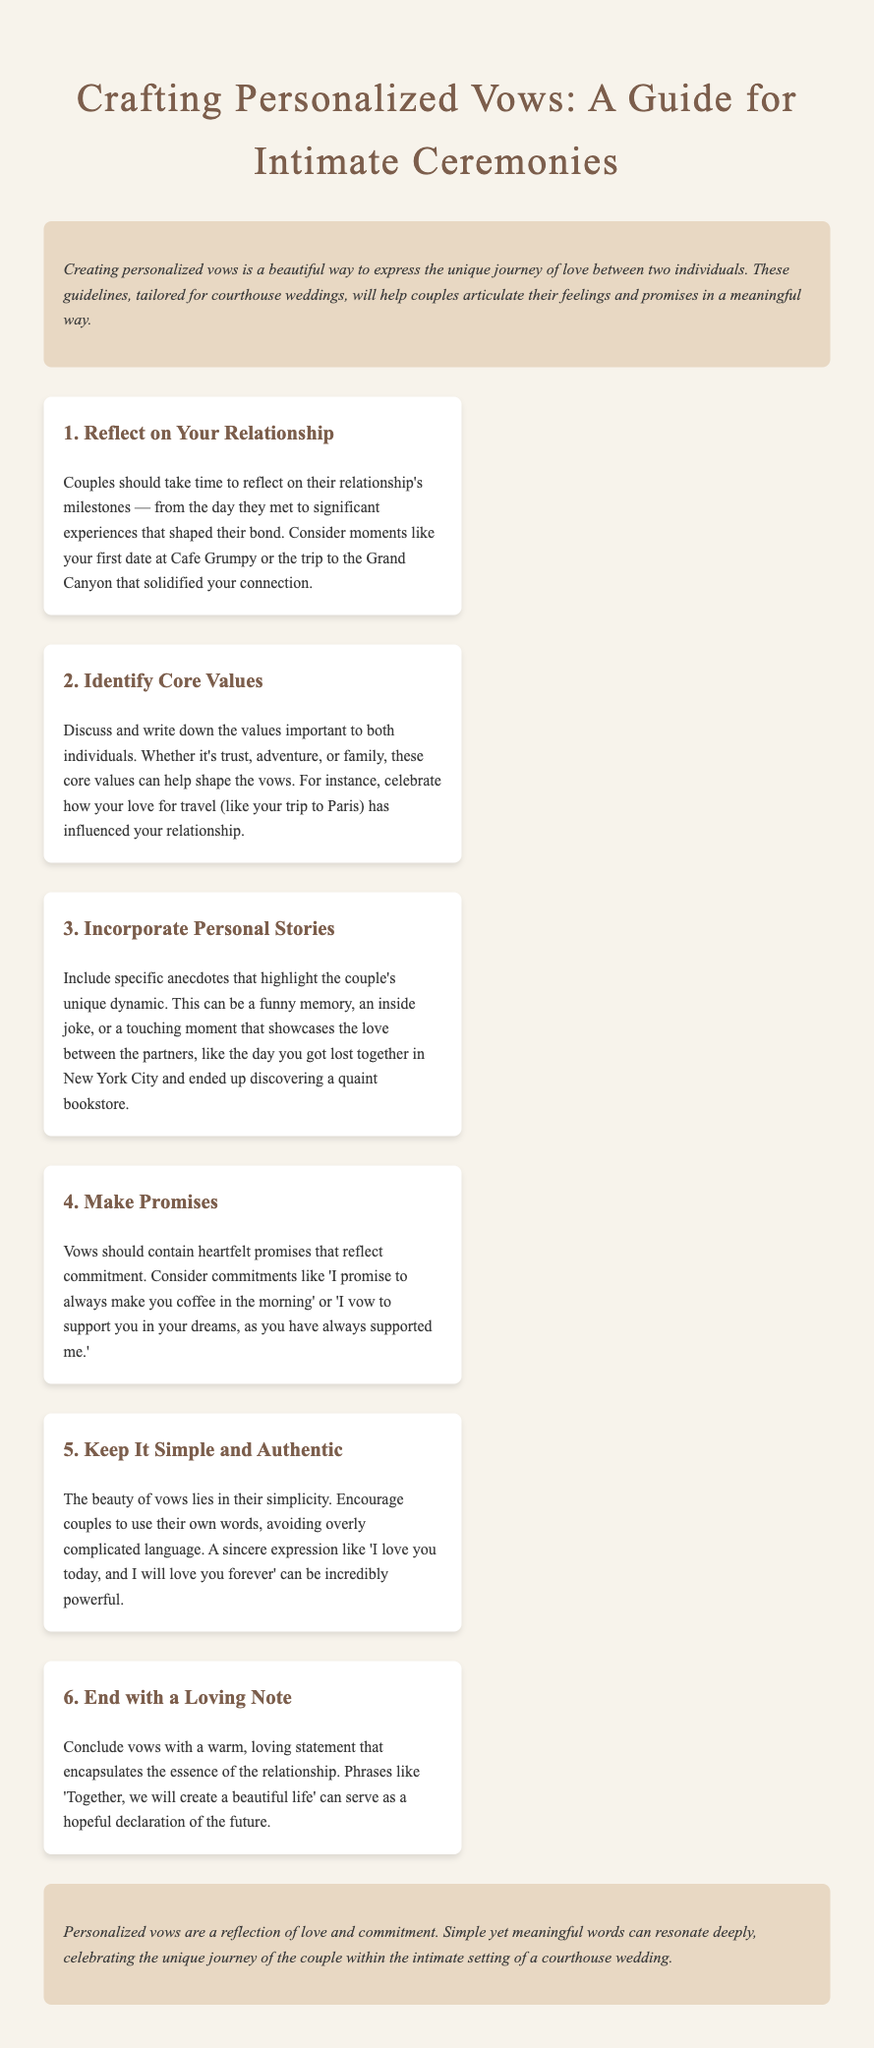What is the title of the document? The title is stated at the top of the document, reflecting the content about crafting personalized vows.
Answer: Crafting Personalized Vows: A Guide for Intimate Ceremonies How many steps are outlined for crafting vows? The document specifies a series of six steps that guide couples in their vow creation process.
Answer: 6 What is the first step in crafting personalized vows? The first step is described in the first "step" section of the document as the first action couples should take.
Answer: Reflect on Your Relationship Which core value is mentioned as an example? The document provides an illustrative example of a core value related to travel within a couple's relationship.
Answer: Adventure What should vows end with according to the guidelines? The closing part of the vows is focused on expressing a hopeful sentiment about the future.
Answer: A Loving Note What tone do the guidelines suggest for personalized vows? The overall vibe suggested for the vows is indicated to resonate with the nature of love and commitment.
Answer: Simple and Authentic 